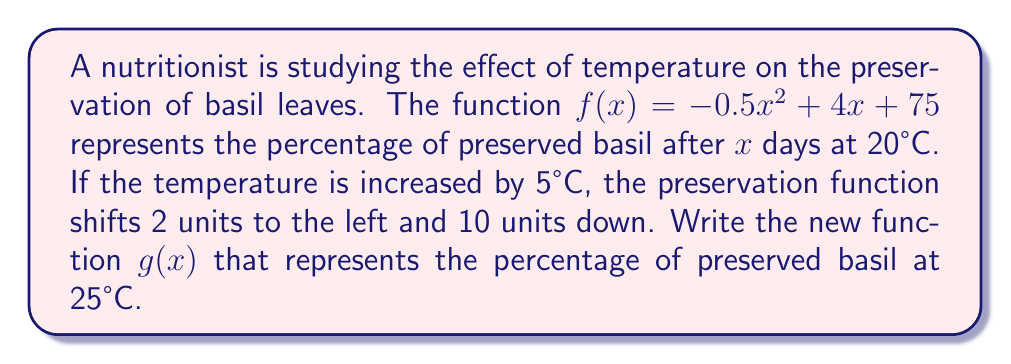Solve this math problem. To solve this problem, we need to apply vertical and horizontal shifts to the original function $f(x)$.

1. Original function: $f(x) = -0.5x^2 + 4x + 75$

2. Horizontal shift:
   The temperature increase causes the function to shift 2 units to the left. This means we replace $x$ with $(x + 2)$ in the original function.
   $f(x + 2) = -0.5(x + 2)^2 + 4(x + 2) + 75$

3. Expand the squared term:
   $f(x + 2) = -0.5(x^2 + 4x + 4) + 4x + 8 + 75$
   $f(x + 2) = -0.5x^2 - 2x - 2 + 4x + 83$
   $f(x + 2) = -0.5x^2 + 2x + 81$

4. Vertical shift:
   The function shifts 10 units down, so we subtract 10 from the constant term.
   $g(x) = -0.5x^2 + 2x + 71$

Therefore, the new function $g(x)$ representing the percentage of preserved basil at 25°C is $g(x) = -0.5x^2 + 2x + 71$.
Answer: $g(x) = -0.5x^2 + 2x + 71$ 